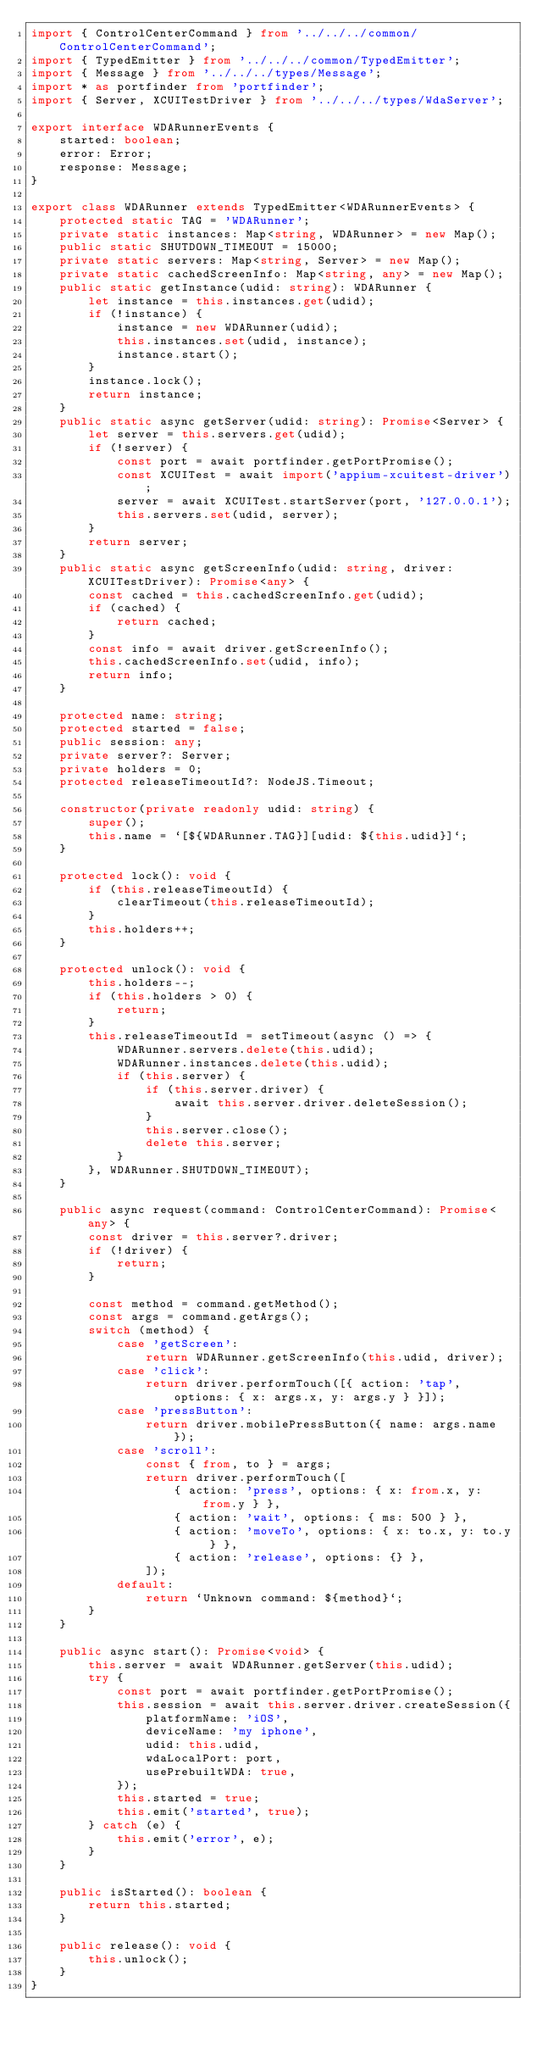Convert code to text. <code><loc_0><loc_0><loc_500><loc_500><_TypeScript_>import { ControlCenterCommand } from '../../../common/ControlCenterCommand';
import { TypedEmitter } from '../../../common/TypedEmitter';
import { Message } from '../../../types/Message';
import * as portfinder from 'portfinder';
import { Server, XCUITestDriver } from '../../../types/WdaServer';

export interface WDARunnerEvents {
    started: boolean;
    error: Error;
    response: Message;
}

export class WDARunner extends TypedEmitter<WDARunnerEvents> {
    protected static TAG = 'WDARunner';
    private static instances: Map<string, WDARunner> = new Map();
    public static SHUTDOWN_TIMEOUT = 15000;
    private static servers: Map<string, Server> = new Map();
    private static cachedScreenInfo: Map<string, any> = new Map();
    public static getInstance(udid: string): WDARunner {
        let instance = this.instances.get(udid);
        if (!instance) {
            instance = new WDARunner(udid);
            this.instances.set(udid, instance);
            instance.start();
        }
        instance.lock();
        return instance;
    }
    public static async getServer(udid: string): Promise<Server> {
        let server = this.servers.get(udid);
        if (!server) {
            const port = await portfinder.getPortPromise();
            const XCUITest = await import('appium-xcuitest-driver');
            server = await XCUITest.startServer(port, '127.0.0.1');
            this.servers.set(udid, server);
        }
        return server;
    }
    public static async getScreenInfo(udid: string, driver: XCUITestDriver): Promise<any> {
        const cached = this.cachedScreenInfo.get(udid);
        if (cached) {
            return cached;
        }
        const info = await driver.getScreenInfo();
        this.cachedScreenInfo.set(udid, info);
        return info;
    }

    protected name: string;
    protected started = false;
    public session: any;
    private server?: Server;
    private holders = 0;
    protected releaseTimeoutId?: NodeJS.Timeout;

    constructor(private readonly udid: string) {
        super();
        this.name = `[${WDARunner.TAG}][udid: ${this.udid}]`;
    }

    protected lock(): void {
        if (this.releaseTimeoutId) {
            clearTimeout(this.releaseTimeoutId);
        }
        this.holders++;
    }

    protected unlock(): void {
        this.holders--;
        if (this.holders > 0) {
            return;
        }
        this.releaseTimeoutId = setTimeout(async () => {
            WDARunner.servers.delete(this.udid);
            WDARunner.instances.delete(this.udid);
            if (this.server) {
                if (this.server.driver) {
                    await this.server.driver.deleteSession();
                }
                this.server.close();
                delete this.server;
            }
        }, WDARunner.SHUTDOWN_TIMEOUT);
    }

    public async request(command: ControlCenterCommand): Promise<any> {
        const driver = this.server?.driver;
        if (!driver) {
            return;
        }

        const method = command.getMethod();
        const args = command.getArgs();
        switch (method) {
            case 'getScreen':
                return WDARunner.getScreenInfo(this.udid, driver);
            case 'click':
                return driver.performTouch([{ action: 'tap', options: { x: args.x, y: args.y } }]);
            case 'pressButton':
                return driver.mobilePressButton({ name: args.name });
            case 'scroll':
                const { from, to } = args;
                return driver.performTouch([
                    { action: 'press', options: { x: from.x, y: from.y } },
                    { action: 'wait', options: { ms: 500 } },
                    { action: 'moveTo', options: { x: to.x, y: to.y } },
                    { action: 'release', options: {} },
                ]);
            default:
                return `Unknown command: ${method}`;
        }
    }

    public async start(): Promise<void> {
        this.server = await WDARunner.getServer(this.udid);
        try {
            const port = await portfinder.getPortPromise();
            this.session = await this.server.driver.createSession({
                platformName: 'iOS',
                deviceName: 'my iphone',
                udid: this.udid,
                wdaLocalPort: port,
                usePrebuiltWDA: true,
            });
            this.started = true;
            this.emit('started', true);
        } catch (e) {
            this.emit('error', e);
        }
    }

    public isStarted(): boolean {
        return this.started;
    }

    public release(): void {
        this.unlock();
    }
}
</code> 